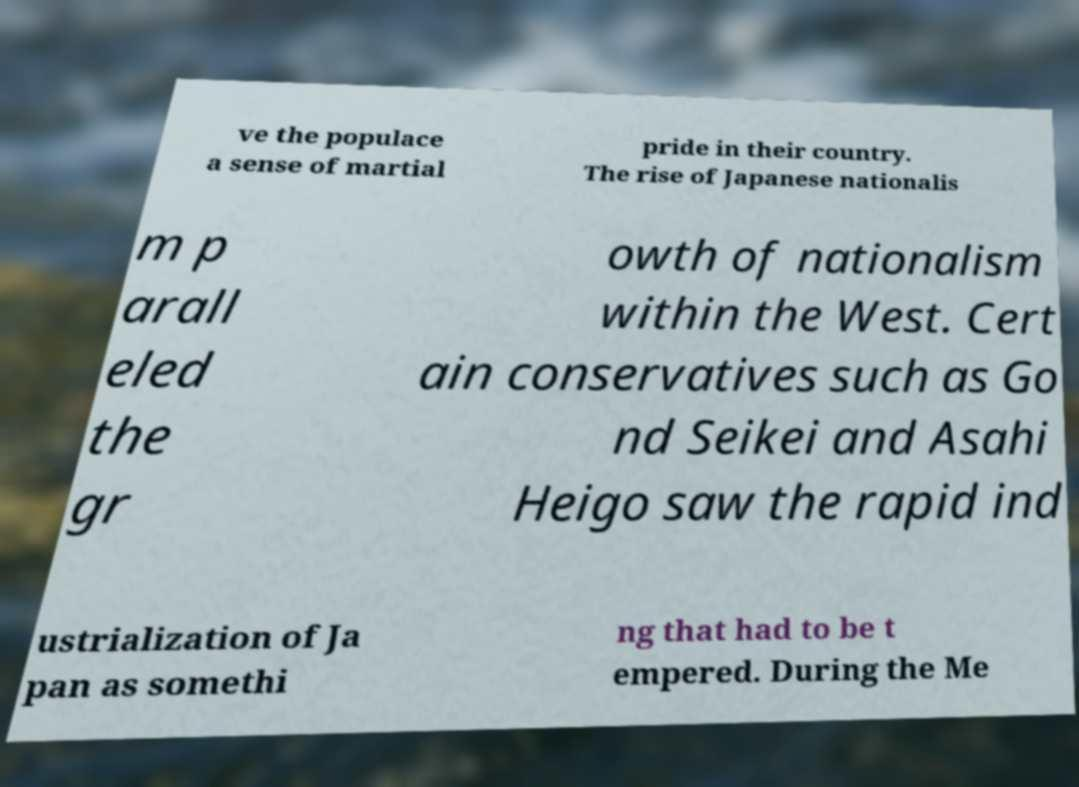I need the written content from this picture converted into text. Can you do that? ve the populace a sense of martial pride in their country. The rise of Japanese nationalis m p arall eled the gr owth of nationalism within the West. Cert ain conservatives such as Go nd Seikei and Asahi Heigo saw the rapid ind ustrialization of Ja pan as somethi ng that had to be t empered. During the Me 